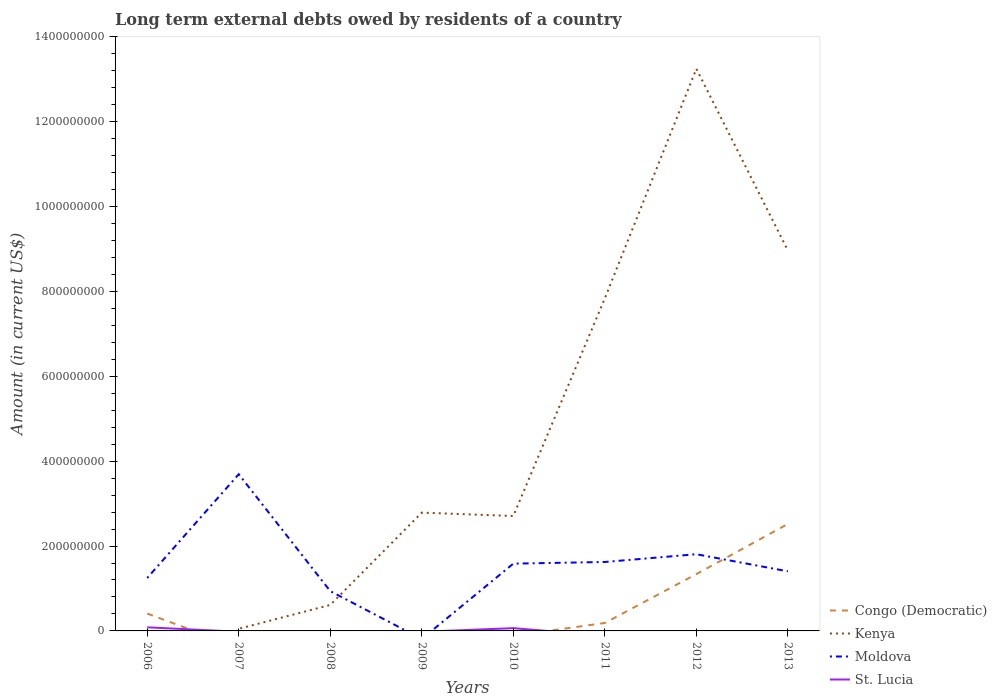Does the line corresponding to Kenya intersect with the line corresponding to Moldova?
Provide a succinct answer. Yes. What is the total amount of long-term external debts owed by residents in Kenya in the graph?
Keep it short and to the point. -1.05e+09. What is the difference between the highest and the second highest amount of long-term external debts owed by residents in Congo (Democratic)?
Keep it short and to the point. 2.52e+08. What is the difference between the highest and the lowest amount of long-term external debts owed by residents in St. Lucia?
Make the answer very short. 2. How many years are there in the graph?
Provide a succinct answer. 8. What is the difference between two consecutive major ticks on the Y-axis?
Give a very brief answer. 2.00e+08. Does the graph contain grids?
Your answer should be very brief. No. Where does the legend appear in the graph?
Provide a succinct answer. Bottom right. How are the legend labels stacked?
Your response must be concise. Vertical. What is the title of the graph?
Ensure brevity in your answer.  Long term external debts owed by residents of a country. Does "East Asia (all income levels)" appear as one of the legend labels in the graph?
Give a very brief answer. No. What is the Amount (in current US$) of Congo (Democratic) in 2006?
Keep it short and to the point. 4.09e+07. What is the Amount (in current US$) in Moldova in 2006?
Provide a short and direct response. 1.25e+08. What is the Amount (in current US$) of St. Lucia in 2006?
Keep it short and to the point. 8.48e+06. What is the Amount (in current US$) in Kenya in 2007?
Offer a terse response. 4.97e+06. What is the Amount (in current US$) in Moldova in 2007?
Ensure brevity in your answer.  3.69e+08. What is the Amount (in current US$) in St. Lucia in 2007?
Keep it short and to the point. 0. What is the Amount (in current US$) in Kenya in 2008?
Your answer should be very brief. 6.13e+07. What is the Amount (in current US$) of Moldova in 2008?
Keep it short and to the point. 9.38e+07. What is the Amount (in current US$) in St. Lucia in 2008?
Provide a short and direct response. 0. What is the Amount (in current US$) of Kenya in 2009?
Make the answer very short. 2.79e+08. What is the Amount (in current US$) of Moldova in 2009?
Offer a terse response. 0. What is the Amount (in current US$) in Congo (Democratic) in 2010?
Keep it short and to the point. 0. What is the Amount (in current US$) of Kenya in 2010?
Provide a succinct answer. 2.71e+08. What is the Amount (in current US$) of Moldova in 2010?
Provide a short and direct response. 1.59e+08. What is the Amount (in current US$) in St. Lucia in 2010?
Provide a succinct answer. 6.51e+06. What is the Amount (in current US$) in Congo (Democratic) in 2011?
Your answer should be compact. 1.87e+07. What is the Amount (in current US$) of Kenya in 2011?
Keep it short and to the point. 7.84e+08. What is the Amount (in current US$) in Moldova in 2011?
Offer a terse response. 1.62e+08. What is the Amount (in current US$) in St. Lucia in 2011?
Provide a succinct answer. 0. What is the Amount (in current US$) of Congo (Democratic) in 2012?
Provide a succinct answer. 1.34e+08. What is the Amount (in current US$) of Kenya in 2012?
Your answer should be very brief. 1.32e+09. What is the Amount (in current US$) in Moldova in 2012?
Give a very brief answer. 1.81e+08. What is the Amount (in current US$) in St. Lucia in 2012?
Offer a terse response. 0. What is the Amount (in current US$) in Congo (Democratic) in 2013?
Offer a very short reply. 2.52e+08. What is the Amount (in current US$) in Kenya in 2013?
Your response must be concise. 8.96e+08. What is the Amount (in current US$) in Moldova in 2013?
Your response must be concise. 1.40e+08. What is the Amount (in current US$) in St. Lucia in 2013?
Ensure brevity in your answer.  0. Across all years, what is the maximum Amount (in current US$) in Congo (Democratic)?
Keep it short and to the point. 2.52e+08. Across all years, what is the maximum Amount (in current US$) in Kenya?
Provide a short and direct response. 1.32e+09. Across all years, what is the maximum Amount (in current US$) in Moldova?
Offer a very short reply. 3.69e+08. Across all years, what is the maximum Amount (in current US$) in St. Lucia?
Offer a very short reply. 8.48e+06. What is the total Amount (in current US$) of Congo (Democratic) in the graph?
Give a very brief answer. 4.46e+08. What is the total Amount (in current US$) of Kenya in the graph?
Keep it short and to the point. 3.62e+09. What is the total Amount (in current US$) of Moldova in the graph?
Provide a short and direct response. 1.23e+09. What is the total Amount (in current US$) in St. Lucia in the graph?
Your response must be concise. 1.50e+07. What is the difference between the Amount (in current US$) in Moldova in 2006 and that in 2007?
Your response must be concise. -2.45e+08. What is the difference between the Amount (in current US$) of Moldova in 2006 and that in 2008?
Keep it short and to the point. 3.09e+07. What is the difference between the Amount (in current US$) of Moldova in 2006 and that in 2010?
Offer a very short reply. -3.39e+07. What is the difference between the Amount (in current US$) in St. Lucia in 2006 and that in 2010?
Offer a terse response. 1.97e+06. What is the difference between the Amount (in current US$) in Congo (Democratic) in 2006 and that in 2011?
Provide a short and direct response. 2.22e+07. What is the difference between the Amount (in current US$) in Moldova in 2006 and that in 2011?
Keep it short and to the point. -3.78e+07. What is the difference between the Amount (in current US$) of Congo (Democratic) in 2006 and that in 2012?
Offer a very short reply. -9.30e+07. What is the difference between the Amount (in current US$) of Moldova in 2006 and that in 2012?
Your answer should be very brief. -5.60e+07. What is the difference between the Amount (in current US$) of Congo (Democratic) in 2006 and that in 2013?
Ensure brevity in your answer.  -2.11e+08. What is the difference between the Amount (in current US$) in Moldova in 2006 and that in 2013?
Offer a terse response. -1.57e+07. What is the difference between the Amount (in current US$) of Kenya in 2007 and that in 2008?
Provide a short and direct response. -5.63e+07. What is the difference between the Amount (in current US$) in Moldova in 2007 and that in 2008?
Give a very brief answer. 2.75e+08. What is the difference between the Amount (in current US$) in Kenya in 2007 and that in 2009?
Offer a very short reply. -2.74e+08. What is the difference between the Amount (in current US$) of Kenya in 2007 and that in 2010?
Give a very brief answer. -2.66e+08. What is the difference between the Amount (in current US$) of Moldova in 2007 and that in 2010?
Offer a very short reply. 2.11e+08. What is the difference between the Amount (in current US$) of Kenya in 2007 and that in 2011?
Give a very brief answer. -7.79e+08. What is the difference between the Amount (in current US$) of Moldova in 2007 and that in 2011?
Your answer should be compact. 2.07e+08. What is the difference between the Amount (in current US$) of Kenya in 2007 and that in 2012?
Ensure brevity in your answer.  -1.32e+09. What is the difference between the Amount (in current US$) of Moldova in 2007 and that in 2012?
Give a very brief answer. 1.88e+08. What is the difference between the Amount (in current US$) of Kenya in 2007 and that in 2013?
Provide a succinct answer. -8.91e+08. What is the difference between the Amount (in current US$) of Moldova in 2007 and that in 2013?
Your answer should be very brief. 2.29e+08. What is the difference between the Amount (in current US$) of Kenya in 2008 and that in 2009?
Offer a very short reply. -2.18e+08. What is the difference between the Amount (in current US$) in Kenya in 2008 and that in 2010?
Offer a very short reply. -2.10e+08. What is the difference between the Amount (in current US$) in Moldova in 2008 and that in 2010?
Make the answer very short. -6.48e+07. What is the difference between the Amount (in current US$) in Kenya in 2008 and that in 2011?
Offer a terse response. -7.22e+08. What is the difference between the Amount (in current US$) in Moldova in 2008 and that in 2011?
Offer a very short reply. -6.87e+07. What is the difference between the Amount (in current US$) in Kenya in 2008 and that in 2012?
Provide a short and direct response. -1.26e+09. What is the difference between the Amount (in current US$) of Moldova in 2008 and that in 2012?
Provide a short and direct response. -8.70e+07. What is the difference between the Amount (in current US$) of Kenya in 2008 and that in 2013?
Give a very brief answer. -8.35e+08. What is the difference between the Amount (in current US$) of Moldova in 2008 and that in 2013?
Your answer should be very brief. -4.67e+07. What is the difference between the Amount (in current US$) in Kenya in 2009 and that in 2010?
Your answer should be compact. 7.98e+06. What is the difference between the Amount (in current US$) in Kenya in 2009 and that in 2011?
Provide a succinct answer. -5.05e+08. What is the difference between the Amount (in current US$) in Kenya in 2009 and that in 2012?
Your answer should be compact. -1.05e+09. What is the difference between the Amount (in current US$) in Kenya in 2009 and that in 2013?
Offer a terse response. -6.18e+08. What is the difference between the Amount (in current US$) of Kenya in 2010 and that in 2011?
Keep it short and to the point. -5.13e+08. What is the difference between the Amount (in current US$) of Moldova in 2010 and that in 2011?
Ensure brevity in your answer.  -3.92e+06. What is the difference between the Amount (in current US$) of Kenya in 2010 and that in 2012?
Offer a very short reply. -1.05e+09. What is the difference between the Amount (in current US$) in Moldova in 2010 and that in 2012?
Offer a terse response. -2.22e+07. What is the difference between the Amount (in current US$) of Kenya in 2010 and that in 2013?
Offer a very short reply. -6.26e+08. What is the difference between the Amount (in current US$) in Moldova in 2010 and that in 2013?
Your response must be concise. 1.81e+07. What is the difference between the Amount (in current US$) in Congo (Democratic) in 2011 and that in 2012?
Provide a succinct answer. -1.15e+08. What is the difference between the Amount (in current US$) in Kenya in 2011 and that in 2012?
Provide a short and direct response. -5.41e+08. What is the difference between the Amount (in current US$) in Moldova in 2011 and that in 2012?
Offer a very short reply. -1.83e+07. What is the difference between the Amount (in current US$) in Congo (Democratic) in 2011 and that in 2013?
Ensure brevity in your answer.  -2.33e+08. What is the difference between the Amount (in current US$) in Kenya in 2011 and that in 2013?
Provide a short and direct response. -1.13e+08. What is the difference between the Amount (in current US$) in Moldova in 2011 and that in 2013?
Keep it short and to the point. 2.20e+07. What is the difference between the Amount (in current US$) of Congo (Democratic) in 2012 and that in 2013?
Your answer should be compact. -1.18e+08. What is the difference between the Amount (in current US$) in Kenya in 2012 and that in 2013?
Offer a very short reply. 4.28e+08. What is the difference between the Amount (in current US$) of Moldova in 2012 and that in 2013?
Keep it short and to the point. 4.03e+07. What is the difference between the Amount (in current US$) of Congo (Democratic) in 2006 and the Amount (in current US$) of Kenya in 2007?
Keep it short and to the point. 3.59e+07. What is the difference between the Amount (in current US$) in Congo (Democratic) in 2006 and the Amount (in current US$) in Moldova in 2007?
Your response must be concise. -3.28e+08. What is the difference between the Amount (in current US$) in Congo (Democratic) in 2006 and the Amount (in current US$) in Kenya in 2008?
Give a very brief answer. -2.04e+07. What is the difference between the Amount (in current US$) of Congo (Democratic) in 2006 and the Amount (in current US$) of Moldova in 2008?
Offer a very short reply. -5.29e+07. What is the difference between the Amount (in current US$) in Congo (Democratic) in 2006 and the Amount (in current US$) in Kenya in 2009?
Provide a succinct answer. -2.38e+08. What is the difference between the Amount (in current US$) of Congo (Democratic) in 2006 and the Amount (in current US$) of Kenya in 2010?
Make the answer very short. -2.30e+08. What is the difference between the Amount (in current US$) in Congo (Democratic) in 2006 and the Amount (in current US$) in Moldova in 2010?
Give a very brief answer. -1.18e+08. What is the difference between the Amount (in current US$) of Congo (Democratic) in 2006 and the Amount (in current US$) of St. Lucia in 2010?
Your answer should be compact. 3.44e+07. What is the difference between the Amount (in current US$) of Moldova in 2006 and the Amount (in current US$) of St. Lucia in 2010?
Provide a short and direct response. 1.18e+08. What is the difference between the Amount (in current US$) in Congo (Democratic) in 2006 and the Amount (in current US$) in Kenya in 2011?
Offer a very short reply. -7.43e+08. What is the difference between the Amount (in current US$) in Congo (Democratic) in 2006 and the Amount (in current US$) in Moldova in 2011?
Provide a short and direct response. -1.22e+08. What is the difference between the Amount (in current US$) of Congo (Democratic) in 2006 and the Amount (in current US$) of Kenya in 2012?
Your response must be concise. -1.28e+09. What is the difference between the Amount (in current US$) in Congo (Democratic) in 2006 and the Amount (in current US$) in Moldova in 2012?
Make the answer very short. -1.40e+08. What is the difference between the Amount (in current US$) of Congo (Democratic) in 2006 and the Amount (in current US$) of Kenya in 2013?
Provide a succinct answer. -8.56e+08. What is the difference between the Amount (in current US$) of Congo (Democratic) in 2006 and the Amount (in current US$) of Moldova in 2013?
Give a very brief answer. -9.95e+07. What is the difference between the Amount (in current US$) in Kenya in 2007 and the Amount (in current US$) in Moldova in 2008?
Offer a very short reply. -8.88e+07. What is the difference between the Amount (in current US$) of Kenya in 2007 and the Amount (in current US$) of Moldova in 2010?
Your answer should be very brief. -1.54e+08. What is the difference between the Amount (in current US$) in Kenya in 2007 and the Amount (in current US$) in St. Lucia in 2010?
Offer a very short reply. -1.55e+06. What is the difference between the Amount (in current US$) in Moldova in 2007 and the Amount (in current US$) in St. Lucia in 2010?
Provide a succinct answer. 3.63e+08. What is the difference between the Amount (in current US$) in Kenya in 2007 and the Amount (in current US$) in Moldova in 2011?
Your answer should be very brief. -1.58e+08. What is the difference between the Amount (in current US$) of Kenya in 2007 and the Amount (in current US$) of Moldova in 2012?
Offer a terse response. -1.76e+08. What is the difference between the Amount (in current US$) in Kenya in 2007 and the Amount (in current US$) in Moldova in 2013?
Your answer should be compact. -1.35e+08. What is the difference between the Amount (in current US$) in Kenya in 2008 and the Amount (in current US$) in Moldova in 2010?
Keep it short and to the point. -9.73e+07. What is the difference between the Amount (in current US$) of Kenya in 2008 and the Amount (in current US$) of St. Lucia in 2010?
Provide a succinct answer. 5.47e+07. What is the difference between the Amount (in current US$) in Moldova in 2008 and the Amount (in current US$) in St. Lucia in 2010?
Your answer should be compact. 8.73e+07. What is the difference between the Amount (in current US$) of Kenya in 2008 and the Amount (in current US$) of Moldova in 2011?
Keep it short and to the point. -1.01e+08. What is the difference between the Amount (in current US$) of Kenya in 2008 and the Amount (in current US$) of Moldova in 2012?
Ensure brevity in your answer.  -1.19e+08. What is the difference between the Amount (in current US$) of Kenya in 2008 and the Amount (in current US$) of Moldova in 2013?
Keep it short and to the point. -7.92e+07. What is the difference between the Amount (in current US$) in Kenya in 2009 and the Amount (in current US$) in Moldova in 2010?
Your answer should be very brief. 1.20e+08. What is the difference between the Amount (in current US$) of Kenya in 2009 and the Amount (in current US$) of St. Lucia in 2010?
Your answer should be very brief. 2.72e+08. What is the difference between the Amount (in current US$) in Kenya in 2009 and the Amount (in current US$) in Moldova in 2011?
Offer a terse response. 1.16e+08. What is the difference between the Amount (in current US$) in Kenya in 2009 and the Amount (in current US$) in Moldova in 2012?
Your answer should be compact. 9.80e+07. What is the difference between the Amount (in current US$) of Kenya in 2009 and the Amount (in current US$) of Moldova in 2013?
Your answer should be very brief. 1.38e+08. What is the difference between the Amount (in current US$) of Kenya in 2010 and the Amount (in current US$) of Moldova in 2011?
Give a very brief answer. 1.08e+08. What is the difference between the Amount (in current US$) of Kenya in 2010 and the Amount (in current US$) of Moldova in 2012?
Keep it short and to the point. 9.01e+07. What is the difference between the Amount (in current US$) of Kenya in 2010 and the Amount (in current US$) of Moldova in 2013?
Ensure brevity in your answer.  1.30e+08. What is the difference between the Amount (in current US$) of Congo (Democratic) in 2011 and the Amount (in current US$) of Kenya in 2012?
Offer a very short reply. -1.31e+09. What is the difference between the Amount (in current US$) of Congo (Democratic) in 2011 and the Amount (in current US$) of Moldova in 2012?
Provide a short and direct response. -1.62e+08. What is the difference between the Amount (in current US$) in Kenya in 2011 and the Amount (in current US$) in Moldova in 2012?
Give a very brief answer. 6.03e+08. What is the difference between the Amount (in current US$) in Congo (Democratic) in 2011 and the Amount (in current US$) in Kenya in 2013?
Ensure brevity in your answer.  -8.78e+08. What is the difference between the Amount (in current US$) in Congo (Democratic) in 2011 and the Amount (in current US$) in Moldova in 2013?
Offer a very short reply. -1.22e+08. What is the difference between the Amount (in current US$) in Kenya in 2011 and the Amount (in current US$) in Moldova in 2013?
Ensure brevity in your answer.  6.43e+08. What is the difference between the Amount (in current US$) in Congo (Democratic) in 2012 and the Amount (in current US$) in Kenya in 2013?
Keep it short and to the point. -7.63e+08. What is the difference between the Amount (in current US$) in Congo (Democratic) in 2012 and the Amount (in current US$) in Moldova in 2013?
Offer a very short reply. -6.52e+06. What is the difference between the Amount (in current US$) in Kenya in 2012 and the Amount (in current US$) in Moldova in 2013?
Your answer should be very brief. 1.18e+09. What is the average Amount (in current US$) of Congo (Democratic) per year?
Your answer should be very brief. 5.57e+07. What is the average Amount (in current US$) in Kenya per year?
Provide a succinct answer. 4.53e+08. What is the average Amount (in current US$) of Moldova per year?
Offer a very short reply. 1.54e+08. What is the average Amount (in current US$) of St. Lucia per year?
Provide a succinct answer. 1.87e+06. In the year 2006, what is the difference between the Amount (in current US$) of Congo (Democratic) and Amount (in current US$) of Moldova?
Keep it short and to the point. -8.38e+07. In the year 2006, what is the difference between the Amount (in current US$) in Congo (Democratic) and Amount (in current US$) in St. Lucia?
Provide a succinct answer. 3.24e+07. In the year 2006, what is the difference between the Amount (in current US$) in Moldova and Amount (in current US$) in St. Lucia?
Your answer should be compact. 1.16e+08. In the year 2007, what is the difference between the Amount (in current US$) in Kenya and Amount (in current US$) in Moldova?
Your answer should be compact. -3.64e+08. In the year 2008, what is the difference between the Amount (in current US$) in Kenya and Amount (in current US$) in Moldova?
Keep it short and to the point. -3.25e+07. In the year 2010, what is the difference between the Amount (in current US$) in Kenya and Amount (in current US$) in Moldova?
Your response must be concise. 1.12e+08. In the year 2010, what is the difference between the Amount (in current US$) of Kenya and Amount (in current US$) of St. Lucia?
Make the answer very short. 2.64e+08. In the year 2010, what is the difference between the Amount (in current US$) of Moldova and Amount (in current US$) of St. Lucia?
Keep it short and to the point. 1.52e+08. In the year 2011, what is the difference between the Amount (in current US$) in Congo (Democratic) and Amount (in current US$) in Kenya?
Provide a succinct answer. -7.65e+08. In the year 2011, what is the difference between the Amount (in current US$) in Congo (Democratic) and Amount (in current US$) in Moldova?
Provide a succinct answer. -1.44e+08. In the year 2011, what is the difference between the Amount (in current US$) in Kenya and Amount (in current US$) in Moldova?
Offer a very short reply. 6.21e+08. In the year 2012, what is the difference between the Amount (in current US$) in Congo (Democratic) and Amount (in current US$) in Kenya?
Provide a succinct answer. -1.19e+09. In the year 2012, what is the difference between the Amount (in current US$) of Congo (Democratic) and Amount (in current US$) of Moldova?
Keep it short and to the point. -4.68e+07. In the year 2012, what is the difference between the Amount (in current US$) in Kenya and Amount (in current US$) in Moldova?
Offer a very short reply. 1.14e+09. In the year 2013, what is the difference between the Amount (in current US$) of Congo (Democratic) and Amount (in current US$) of Kenya?
Provide a short and direct response. -6.44e+08. In the year 2013, what is the difference between the Amount (in current US$) of Congo (Democratic) and Amount (in current US$) of Moldova?
Ensure brevity in your answer.  1.12e+08. In the year 2013, what is the difference between the Amount (in current US$) in Kenya and Amount (in current US$) in Moldova?
Ensure brevity in your answer.  7.56e+08. What is the ratio of the Amount (in current US$) of Moldova in 2006 to that in 2007?
Ensure brevity in your answer.  0.34. What is the ratio of the Amount (in current US$) of Moldova in 2006 to that in 2008?
Offer a terse response. 1.33. What is the ratio of the Amount (in current US$) in Moldova in 2006 to that in 2010?
Make the answer very short. 0.79. What is the ratio of the Amount (in current US$) in St. Lucia in 2006 to that in 2010?
Provide a short and direct response. 1.3. What is the ratio of the Amount (in current US$) in Congo (Democratic) in 2006 to that in 2011?
Provide a succinct answer. 2.18. What is the ratio of the Amount (in current US$) of Moldova in 2006 to that in 2011?
Offer a very short reply. 0.77. What is the ratio of the Amount (in current US$) of Congo (Democratic) in 2006 to that in 2012?
Your answer should be very brief. 0.31. What is the ratio of the Amount (in current US$) of Moldova in 2006 to that in 2012?
Provide a short and direct response. 0.69. What is the ratio of the Amount (in current US$) of Congo (Democratic) in 2006 to that in 2013?
Your answer should be compact. 0.16. What is the ratio of the Amount (in current US$) in Moldova in 2006 to that in 2013?
Your answer should be very brief. 0.89. What is the ratio of the Amount (in current US$) in Kenya in 2007 to that in 2008?
Your response must be concise. 0.08. What is the ratio of the Amount (in current US$) of Moldova in 2007 to that in 2008?
Offer a terse response. 3.94. What is the ratio of the Amount (in current US$) of Kenya in 2007 to that in 2009?
Offer a terse response. 0.02. What is the ratio of the Amount (in current US$) in Kenya in 2007 to that in 2010?
Give a very brief answer. 0.02. What is the ratio of the Amount (in current US$) of Moldova in 2007 to that in 2010?
Your answer should be very brief. 2.33. What is the ratio of the Amount (in current US$) of Kenya in 2007 to that in 2011?
Provide a succinct answer. 0.01. What is the ratio of the Amount (in current US$) in Moldova in 2007 to that in 2011?
Make the answer very short. 2.27. What is the ratio of the Amount (in current US$) of Kenya in 2007 to that in 2012?
Ensure brevity in your answer.  0. What is the ratio of the Amount (in current US$) of Moldova in 2007 to that in 2012?
Keep it short and to the point. 2.04. What is the ratio of the Amount (in current US$) in Kenya in 2007 to that in 2013?
Make the answer very short. 0.01. What is the ratio of the Amount (in current US$) in Moldova in 2007 to that in 2013?
Keep it short and to the point. 2.63. What is the ratio of the Amount (in current US$) in Kenya in 2008 to that in 2009?
Your answer should be compact. 0.22. What is the ratio of the Amount (in current US$) in Kenya in 2008 to that in 2010?
Your response must be concise. 0.23. What is the ratio of the Amount (in current US$) of Moldova in 2008 to that in 2010?
Offer a terse response. 0.59. What is the ratio of the Amount (in current US$) in Kenya in 2008 to that in 2011?
Your answer should be compact. 0.08. What is the ratio of the Amount (in current US$) in Moldova in 2008 to that in 2011?
Provide a succinct answer. 0.58. What is the ratio of the Amount (in current US$) of Kenya in 2008 to that in 2012?
Your answer should be very brief. 0.05. What is the ratio of the Amount (in current US$) in Moldova in 2008 to that in 2012?
Offer a very short reply. 0.52. What is the ratio of the Amount (in current US$) of Kenya in 2008 to that in 2013?
Offer a terse response. 0.07. What is the ratio of the Amount (in current US$) of Moldova in 2008 to that in 2013?
Ensure brevity in your answer.  0.67. What is the ratio of the Amount (in current US$) of Kenya in 2009 to that in 2010?
Keep it short and to the point. 1.03. What is the ratio of the Amount (in current US$) in Kenya in 2009 to that in 2011?
Your response must be concise. 0.36. What is the ratio of the Amount (in current US$) in Kenya in 2009 to that in 2012?
Ensure brevity in your answer.  0.21. What is the ratio of the Amount (in current US$) in Kenya in 2009 to that in 2013?
Ensure brevity in your answer.  0.31. What is the ratio of the Amount (in current US$) in Kenya in 2010 to that in 2011?
Ensure brevity in your answer.  0.35. What is the ratio of the Amount (in current US$) in Moldova in 2010 to that in 2011?
Give a very brief answer. 0.98. What is the ratio of the Amount (in current US$) in Kenya in 2010 to that in 2012?
Make the answer very short. 0.2. What is the ratio of the Amount (in current US$) in Moldova in 2010 to that in 2012?
Your response must be concise. 0.88. What is the ratio of the Amount (in current US$) in Kenya in 2010 to that in 2013?
Offer a very short reply. 0.3. What is the ratio of the Amount (in current US$) of Moldova in 2010 to that in 2013?
Offer a terse response. 1.13. What is the ratio of the Amount (in current US$) of Congo (Democratic) in 2011 to that in 2012?
Your response must be concise. 0.14. What is the ratio of the Amount (in current US$) in Kenya in 2011 to that in 2012?
Offer a very short reply. 0.59. What is the ratio of the Amount (in current US$) of Moldova in 2011 to that in 2012?
Provide a succinct answer. 0.9. What is the ratio of the Amount (in current US$) of Congo (Democratic) in 2011 to that in 2013?
Ensure brevity in your answer.  0.07. What is the ratio of the Amount (in current US$) in Kenya in 2011 to that in 2013?
Keep it short and to the point. 0.87. What is the ratio of the Amount (in current US$) in Moldova in 2011 to that in 2013?
Your answer should be compact. 1.16. What is the ratio of the Amount (in current US$) of Congo (Democratic) in 2012 to that in 2013?
Offer a very short reply. 0.53. What is the ratio of the Amount (in current US$) of Kenya in 2012 to that in 2013?
Give a very brief answer. 1.48. What is the ratio of the Amount (in current US$) of Moldova in 2012 to that in 2013?
Your response must be concise. 1.29. What is the difference between the highest and the second highest Amount (in current US$) of Congo (Democratic)?
Offer a terse response. 1.18e+08. What is the difference between the highest and the second highest Amount (in current US$) of Kenya?
Make the answer very short. 4.28e+08. What is the difference between the highest and the second highest Amount (in current US$) of Moldova?
Provide a short and direct response. 1.88e+08. What is the difference between the highest and the lowest Amount (in current US$) in Congo (Democratic)?
Provide a short and direct response. 2.52e+08. What is the difference between the highest and the lowest Amount (in current US$) of Kenya?
Provide a succinct answer. 1.32e+09. What is the difference between the highest and the lowest Amount (in current US$) in Moldova?
Provide a short and direct response. 3.69e+08. What is the difference between the highest and the lowest Amount (in current US$) of St. Lucia?
Provide a succinct answer. 8.48e+06. 